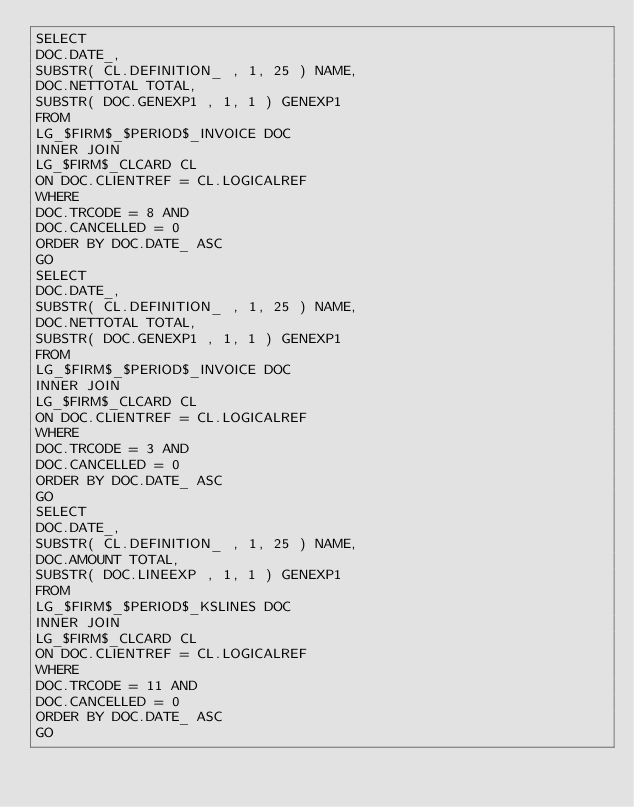<code> <loc_0><loc_0><loc_500><loc_500><_SQL_>SELECT
DOC.DATE_,
SUBSTR( CL.DEFINITION_ , 1, 25 ) NAME,
DOC.NETTOTAL TOTAL,
SUBSTR( DOC.GENEXP1 , 1, 1 ) GENEXP1
FROM 
LG_$FIRM$_$PERIOD$_INVOICE DOC 
INNER JOIN
LG_$FIRM$_CLCARD CL 
ON DOC.CLIENTREF = CL.LOGICALREF
WHERE 
DOC.TRCODE = 8 AND
DOC.CANCELLED = 0 
ORDER BY DOC.DATE_ ASC
GO
SELECT
DOC.DATE_,
SUBSTR( CL.DEFINITION_ , 1, 25 ) NAME,
DOC.NETTOTAL TOTAL,
SUBSTR( DOC.GENEXP1 , 1, 1 ) GENEXP1
FROM 
LG_$FIRM$_$PERIOD$_INVOICE DOC 
INNER JOIN
LG_$FIRM$_CLCARD CL 
ON DOC.CLIENTREF = CL.LOGICALREF
WHERE 
DOC.TRCODE = 3 AND
DOC.CANCELLED = 0 
ORDER BY DOC.DATE_ ASC
GO
SELECT
DOC.DATE_,
SUBSTR( CL.DEFINITION_ , 1, 25 ) NAME,
DOC.AMOUNT TOTAL,
SUBSTR( DOC.LINEEXP , 1, 1 ) GENEXP1
FROM 
LG_$FIRM$_$PERIOD$_KSLINES DOC 
INNER JOIN
LG_$FIRM$_CLCARD CL 
ON DOC.CLIENTREF = CL.LOGICALREF
WHERE 
DOC.TRCODE = 11 AND
DOC.CANCELLED = 0 
ORDER BY DOC.DATE_ ASC
GO

</code> 